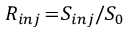<formula> <loc_0><loc_0><loc_500><loc_500>R _ { i n j } \, = \, S _ { i n j } / S _ { 0 }</formula> 